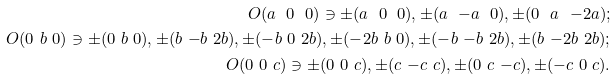Convert formula to latex. <formula><loc_0><loc_0><loc_500><loc_500>O ( a \ 0 \ 0 ) \ni \pm ( a \ 0 \ 0 ) , \pm ( a \ { - } a \ 0 ) , \pm ( 0 \ a \ { - } 2 a ) ; \\ O ( 0 \ b \ 0 ) \ni \pm ( 0 \ b \ 0 ) , \pm ( b \ { - } b \ 2 b ) , \pm ( { - } b \ 0 \ 2 b ) , \pm ( { - } 2 b \ b \ 0 ) , \pm ( { - } b \ { - } b \ 2 b ) , \pm ( b \ { - } 2 b \ 2 b ) ; \\ O ( 0 \ 0 \ c ) \ni \pm ( 0 \ 0 \ c ) , \pm ( c \ { - } c \ c ) , \pm ( 0 \ c \ { - } c ) , \pm ( { - } c \ 0 \ c ) .</formula> 